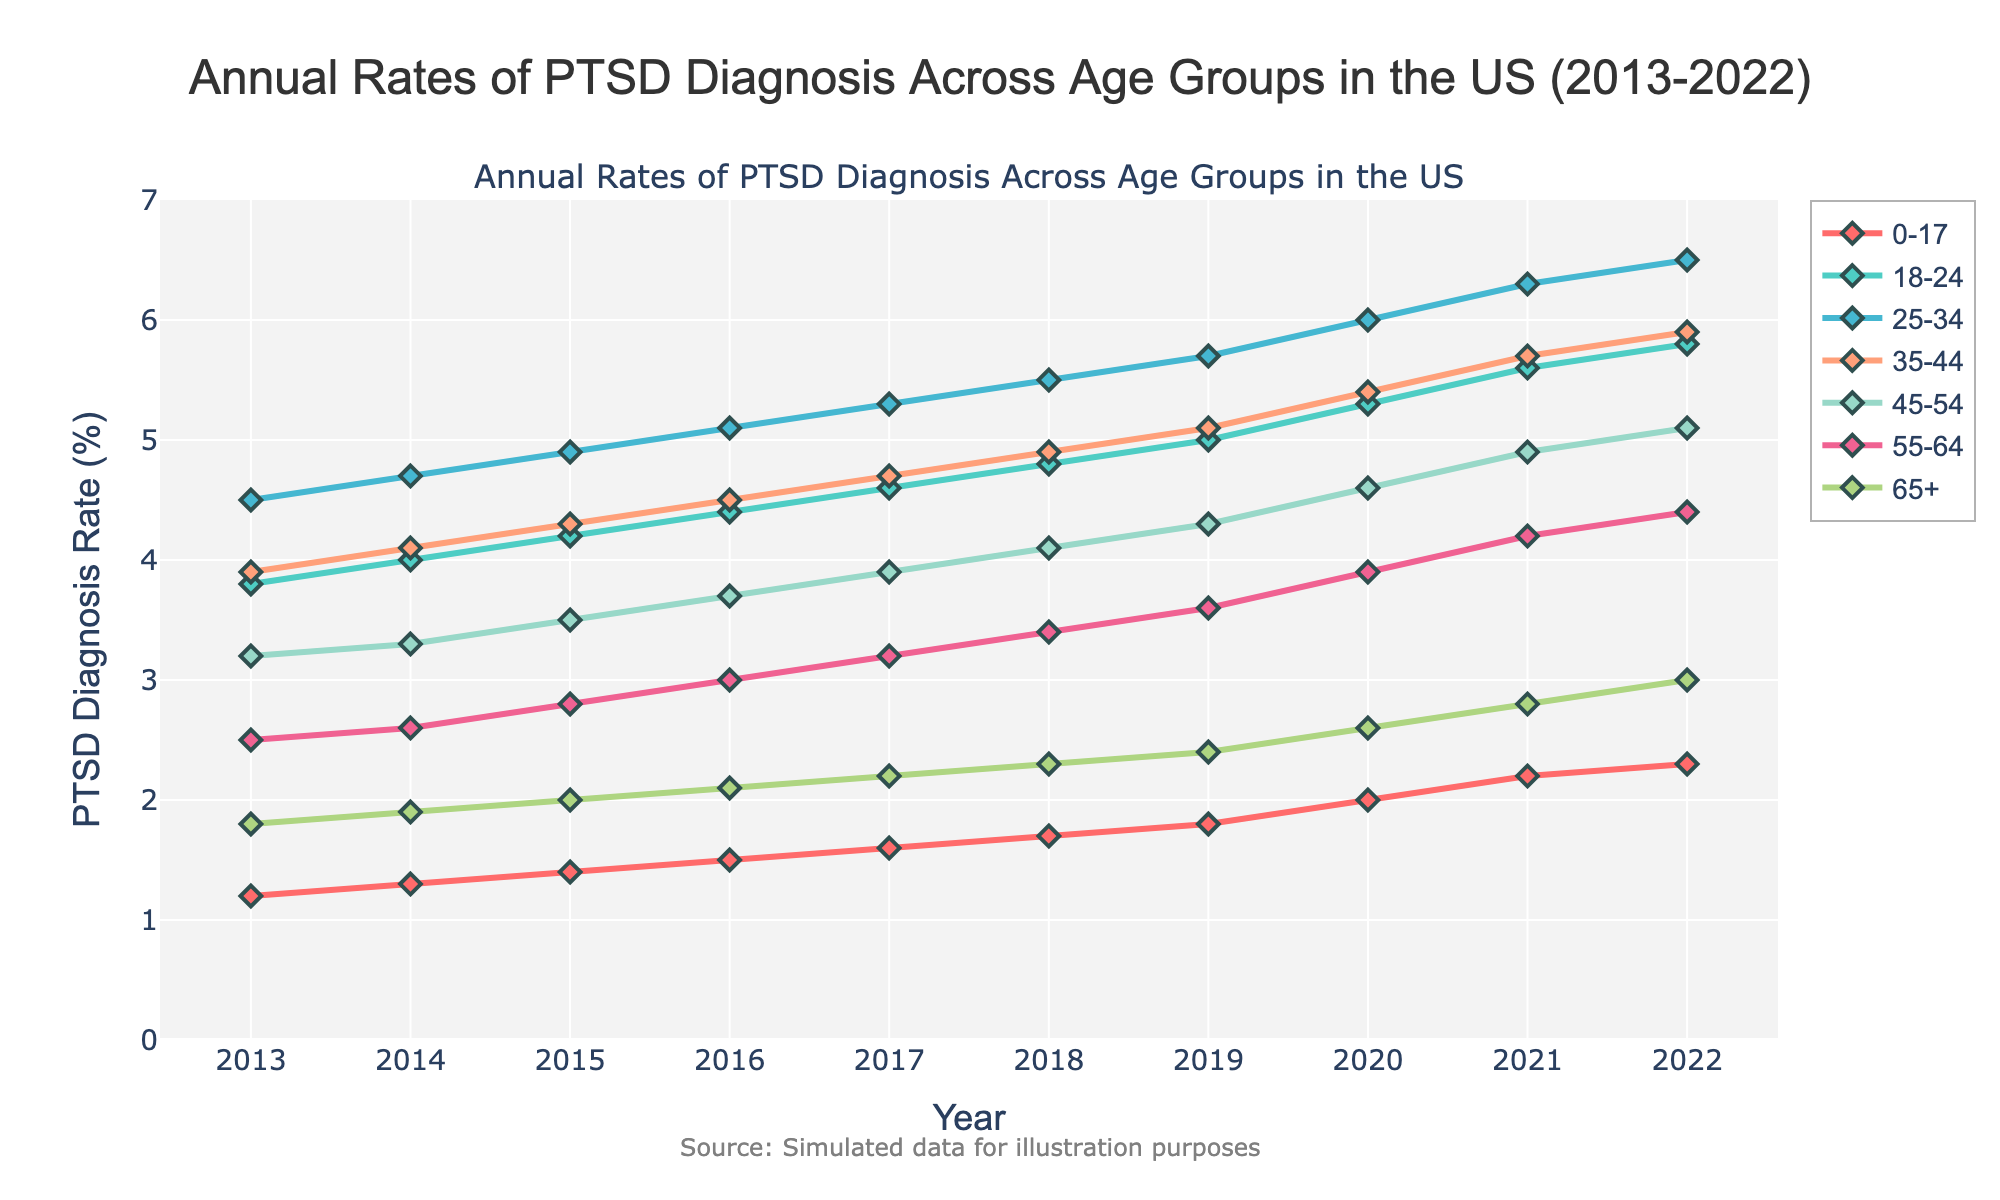What's the trend in the PTSD diagnosis rate for the age group 25-34 from 2013 to 2022? The PTSD diagnosis rate for the age group 25-34 shows a consistent upward trend. It starts at 4.5% in 2013 and gradually increases each year, reaching 6.5% in 2022.
Answer: Upward trend Which age group saw the largest increase in PTSD diagnosis rates from 2013 to 2022? To determine the largest increase, calculate the difference between the rates in 2022 and 2013 for each age group. The age group 25-34 had the largest increase, from 4.5% to 6.5%, a rise of 2%.
Answer: 25-34 In which year did the age group 18-24 first surpass a PTSD diagnosis rate of 5.0%? Examine the rates of the age group 18-24 across the years and identify when the rate first exceeds 5.0%. It crosses 5.0% in 2019.
Answer: 2019 Compare the PTSD diagnosis rates for the age groups 45-54 and 55-64 in 2020. Which one is higher, and by how much? In 2020, the rate for 45-54 is 4.6% and for 55-64 is 3.9%. The rate for 45-54 is higher by 0.7%.
Answer: 45-54 is higher by 0.7% What is the average PTSD diagnosis rate for the age group 0-17 from 2013 to 2022? Sum up the rates for the age group 0-17 from 2013 to 2022 and divide by the number of years. (1.2 + 1.3 + 1.4 + 1.5 + 1.6 + 1.7 + 1.8 + 2.0 + 2.2 + 2.3) / 10 = 1.7%.
Answer: 1.7% Identify the overall trend for the age group 65+ and state whether it is increasing, decreasing or staying the same. The PTSD diagnosis rate for the age group 65+ shows a gentle upward trend, increasing from 1.8% in 2013 to 3.0% in 2022.
Answer: Increasing What is the rate of increase in PTSD diagnosis percentage for the age group 35-44 between 2015 and 2022? Subtract the rate in 2015 from the rate in 2022 for the age group 35-44. The rate in 2015 is 4.3% and in 2022 it is 5.9%. The rate of increase is 1.6%.
Answer: 1.6% For the year 2021, what is the difference in PTSD diagnosis rates between the youngest (0-17) and oldest (65+) age groups? For 2021, the rate for 0-17 is 2.2% and for 65+ it is 2.8%. The difference is 2.8% - 2.2% = 0.6%.
Answer: 0.6% Looking at the colors representing each age group, which color is associated with the age group 18-24? The color associated with the age group 18-24 can be identified as a teal color.
Answer: Teal 